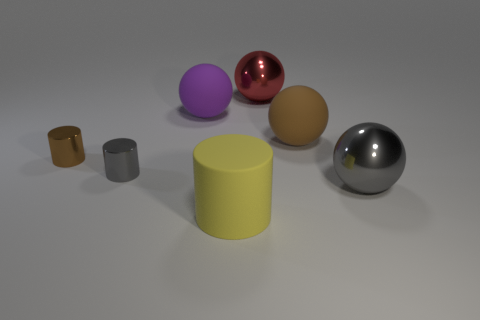There is a large yellow object that is made of the same material as the big purple ball; what is its shape?
Give a very brief answer. Cylinder. What number of rubber things are either gray cylinders or large brown spheres?
Your response must be concise. 1. Are there the same number of red metal balls that are left of the red ball and cylinders?
Offer a very short reply. No. Do the ball that is on the left side of the matte cylinder and the large matte cylinder have the same color?
Your answer should be very brief. No. What is the material of the large sphere that is both left of the brown rubber object and in front of the big red shiny sphere?
Keep it short and to the point. Rubber. Are there any large purple things in front of the small object in front of the brown metal cylinder?
Your answer should be compact. No. Is the material of the small gray cylinder the same as the large brown object?
Provide a short and direct response. No. There is a rubber thing that is to the left of the large brown rubber sphere and behind the brown cylinder; what shape is it?
Your answer should be compact. Sphere. What size is the matte sphere on the left side of the thing in front of the large gray sphere?
Provide a succinct answer. Large. How many large brown matte objects are the same shape as the yellow matte thing?
Ensure brevity in your answer.  0. 